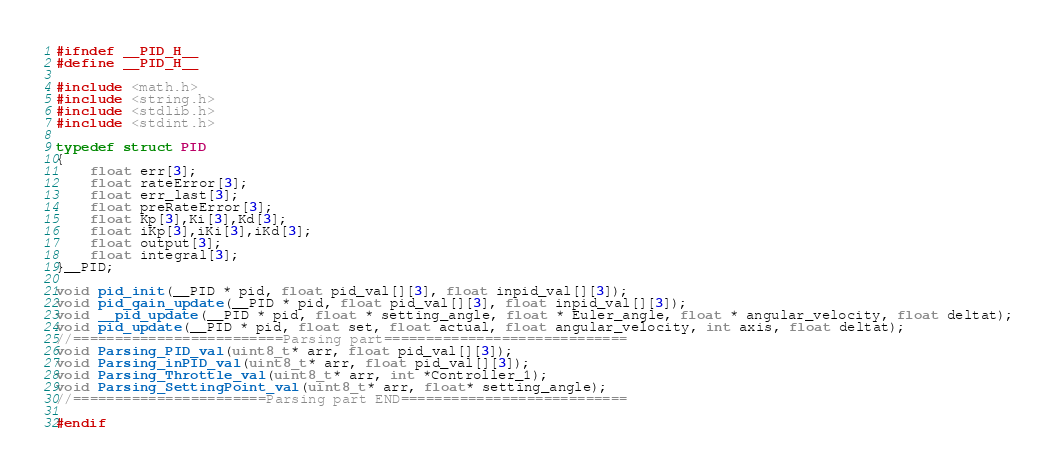<code> <loc_0><loc_0><loc_500><loc_500><_C_>#ifndef __PID_H__
#define __PID_H__

#include <math.h>
#include <string.h>
#include <stdlib.h>
#include <stdint.h>

typedef struct PID
{
	float err[3]; 
    float rateError[3];
	float err_last[3]; 
    float preRateError[3];
	float Kp[3],Ki[3],Kd[3];
    float iKp[3],iKi[3],iKd[3];
	float output[3];
	float integral[3];
}__PID;

void pid_init(__PID * pid, float pid_val[][3], float inpid_val[][3]);
void pid_gain_update(__PID * pid, float pid_val[][3], float inpid_val[][3]);
void __pid_update(__PID * pid, float * setting_angle, float * Euler_angle, float * angular_velocity, float deltat);
void pid_update(__PID * pid, float set, float actual, float angular_velocity, int axis, float deltat);
//=========================Parsing part=============================
void Parsing_PID_val(uint8_t* arr, float pid_val[][3]);
void Parsing_inPID_val(uint8_t* arr, float pid_val[][3]);
void Parsing_Throttle_val(uint8_t* arr, int *Controller_1);
void Parsing_SettingPoint_val(uint8_t* arr, float* setting_angle);
//=======================Parsing part END===========================

#endif

</code> 